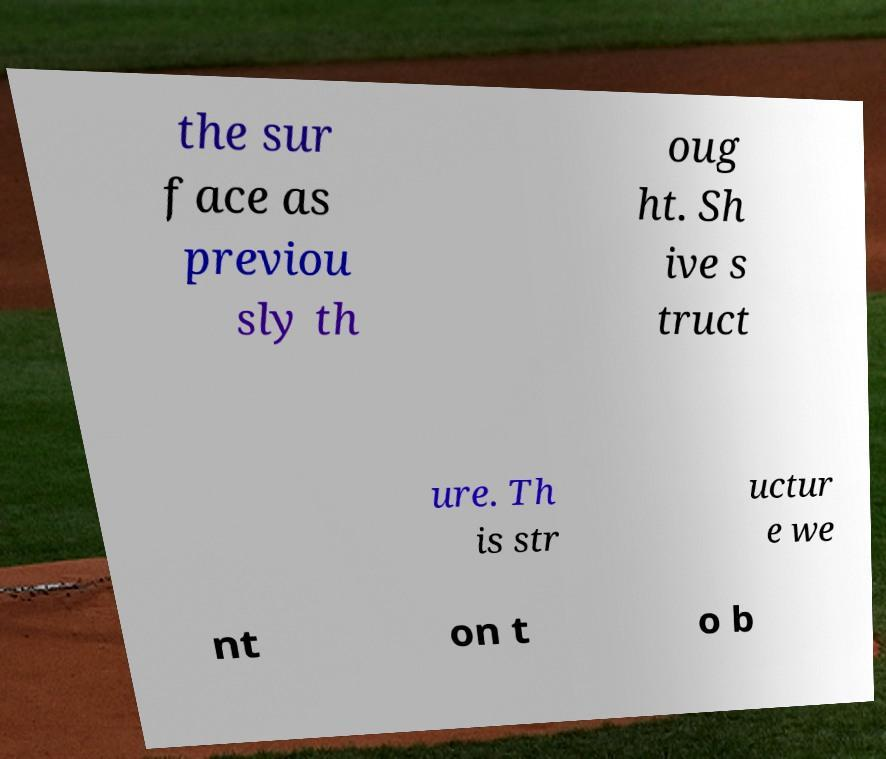What messages or text are displayed in this image? I need them in a readable, typed format. the sur face as previou sly th oug ht. Sh ive s truct ure. Th is str uctur e we nt on t o b 